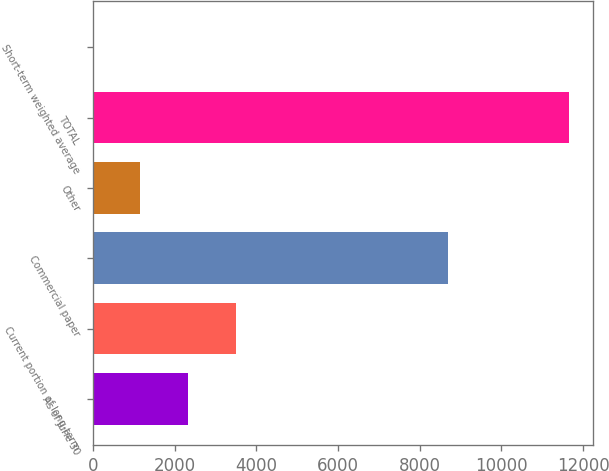Convert chart to OTSL. <chart><loc_0><loc_0><loc_500><loc_500><bar_chart><fcel>As of June 30<fcel>Current portion of long-term<fcel>Commercial paper<fcel>Other<fcel>TOTAL<fcel>Short-term weighted average<nl><fcel>2330.76<fcel>3496.04<fcel>8690<fcel>1165.48<fcel>11653<fcel>0.2<nl></chart> 